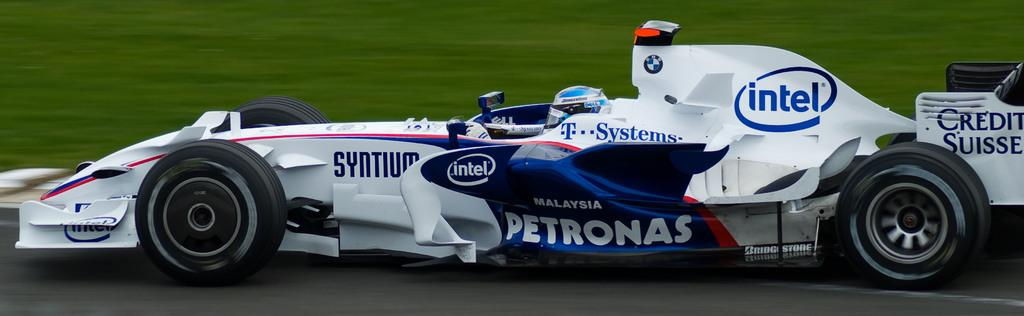What is the main subject of the image? The main subject of the image is a car. Is there anyone else present in the image besides the car? Yes, there is a person in the image. How many pizzas can be seen being sorted by the person in the image? There are no pizzas present in the image, and the person is not shown sorting anything. What color is the nose of the person in the image? The image does not show the person's nose, so it cannot be determined what color it is. 